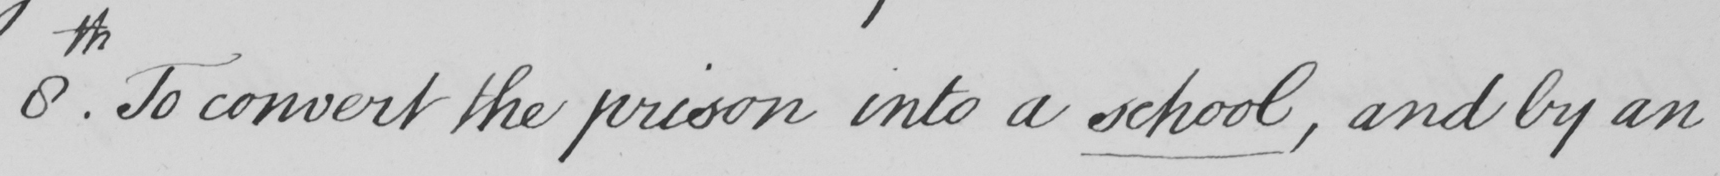What text is written in this handwritten line? 8th . To convert the prison into a school , and by an 